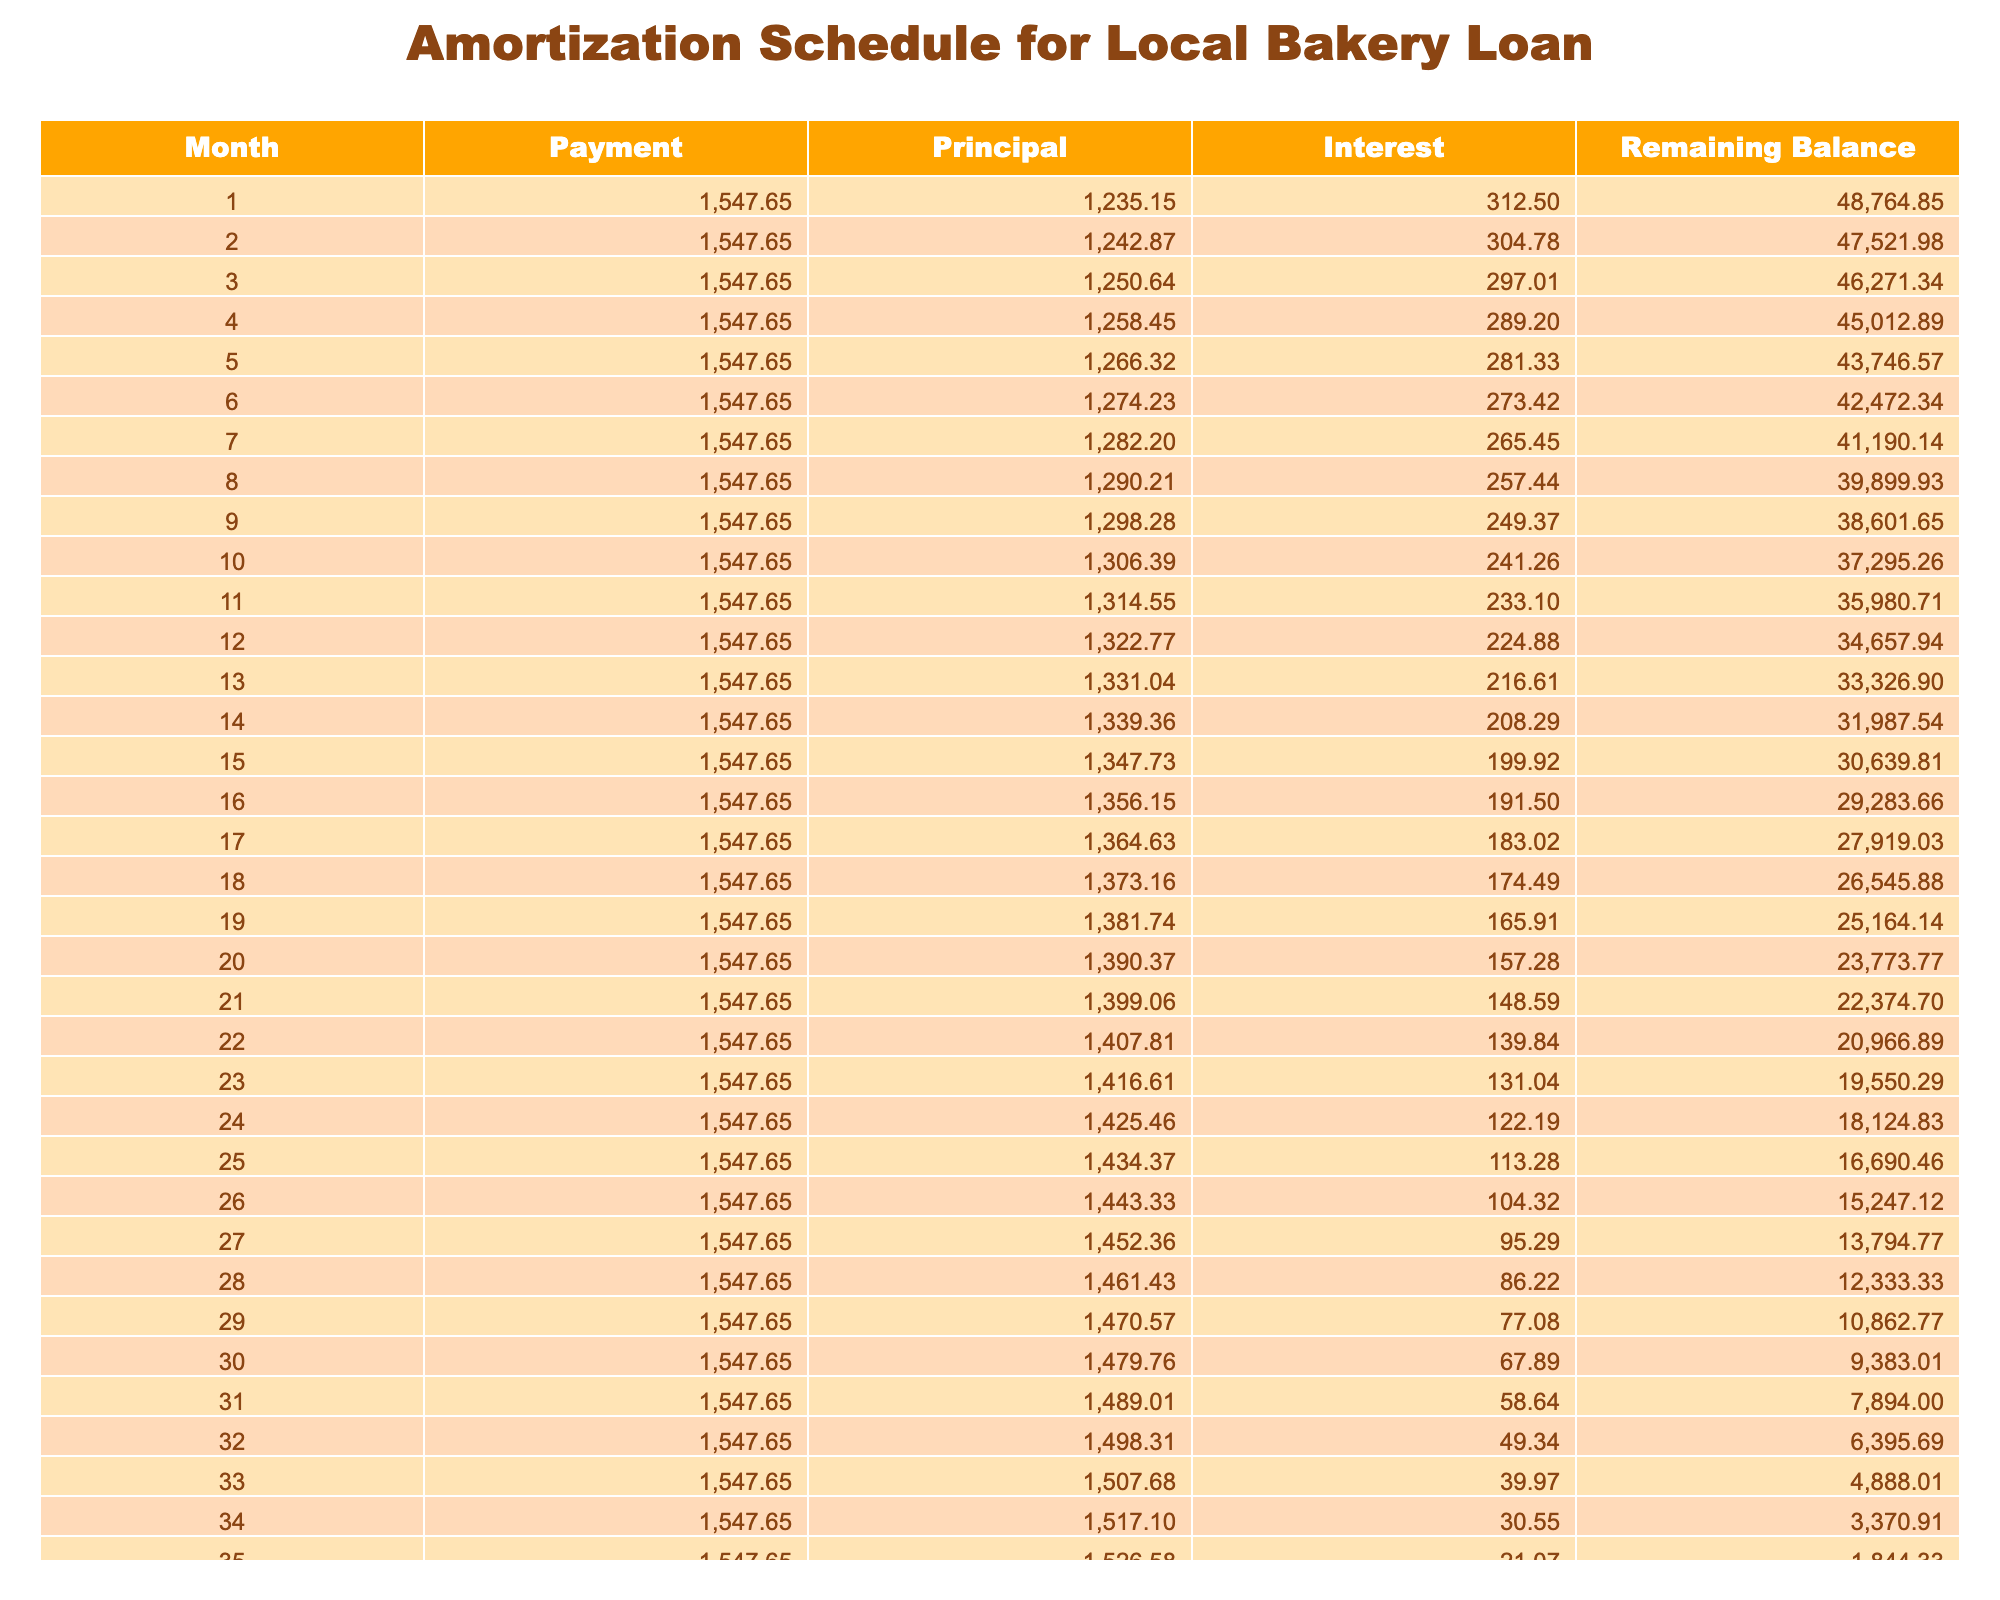What is the total amount paid over the loan term? The total amount paid over the loan term is stated in the table under "Total Payment", which shows a value of 55606.40.
Answer: 55606.40 How much is the monthly payment for this loan? The monthly payment can be found in the table under "Monthly Payment", which lists a value of 1547.65.
Answer: 1547.65 What is the total interest paid during the entire loan period? The total interest is detailed in the table under "Total Interest", showing a value of 5616.40.
Answer: 5616.40 Is the monthly payment less than 2000? Comparing the monthly payment of 1547.65 to 2000, it is evident that 1547.65 is less than 2000.
Answer: Yes What is the remaining balance after 12 months? To find the remaining balance after 12 months, we can look at the "Remaining Balance" column. We would need to check the entry under Month 12, which indicates a remaining balance. Unfortunately, the specific number is not provided here directly, but can be found in the table.
Answer: [To be looked up in the table] What is the average monthly payment over the loan term? Since the monthly payment is fixed at 1547.65 for all months, the average monthly payment is simply 1547.65 itself.
Answer: 1547.65 What is the principal paid in the first month? To find the principal payment for the first month, we check the "Principal" column under Month 1 in the table. The specific value must be looked up in the table for a precise number.
Answer: [To be looked up in the table] Is the total interest paid greater than 5000? Yes, the total interest is listed as 5616.40, which is indeed greater than 5000.
Answer: Yes How much principal is repaid in total by the end of the loan? The total principal repaid is equal to the loan amount, which is 50000, since all principal is repaid at the end of the loan term.
Answer: 50000 